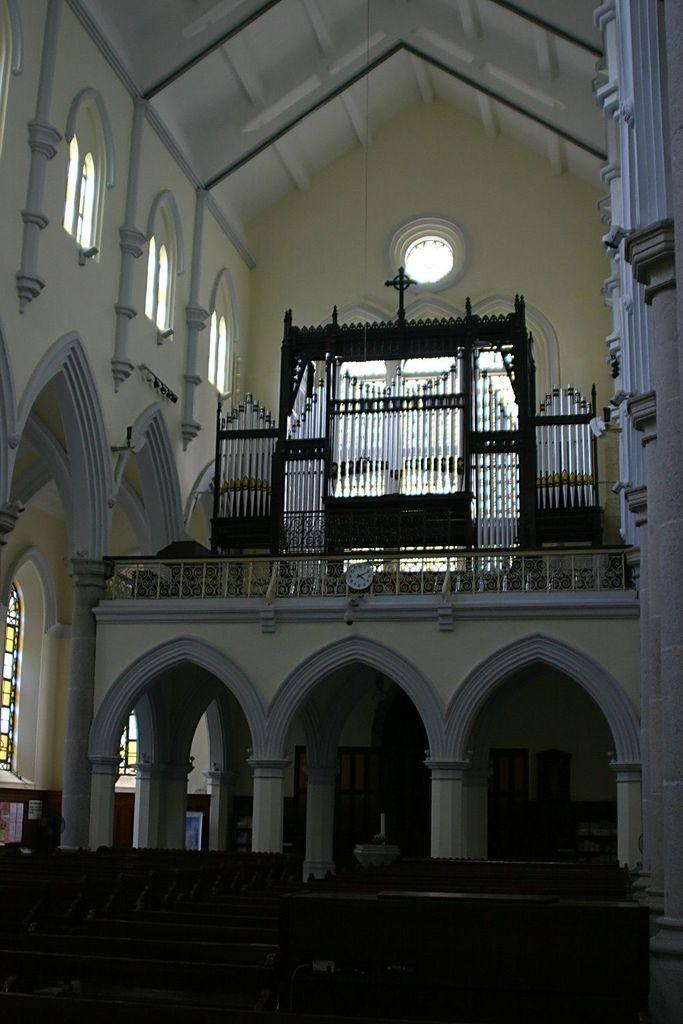What type of building is shown in the image? The image shows the inner view of a church. What type of seating is available in the church? There are wooden benches in the church. What architectural features can be seen in the church? Pillars are present in the church. What time-telling device is present in the church? There is a clock in the church. What religious symbol is visible in the church? A cross symbol is visible in the church. What type of windows are present in the church? Glass windows are present in the church. What part of the church's structure is visible in the background of the image? The ceiling is visible in the background of the image. How many cacti are present in the church? There are no cacti present in the church; the image shows the interior of a church with religious symbols and architectural features. 